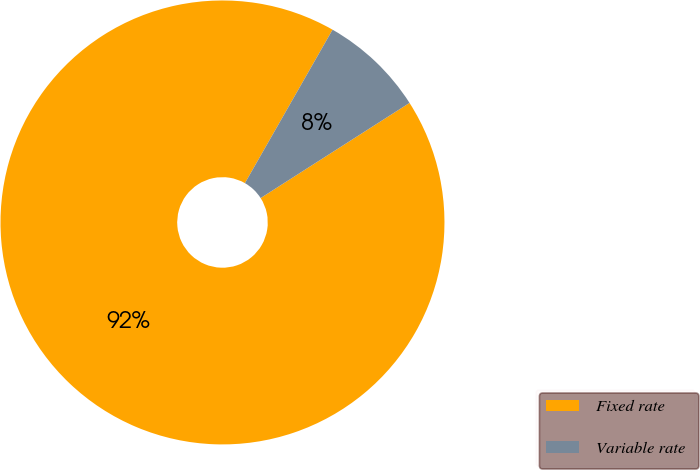Convert chart to OTSL. <chart><loc_0><loc_0><loc_500><loc_500><pie_chart><fcel>Fixed rate<fcel>Variable rate<nl><fcel>92.31%<fcel>7.69%<nl></chart> 